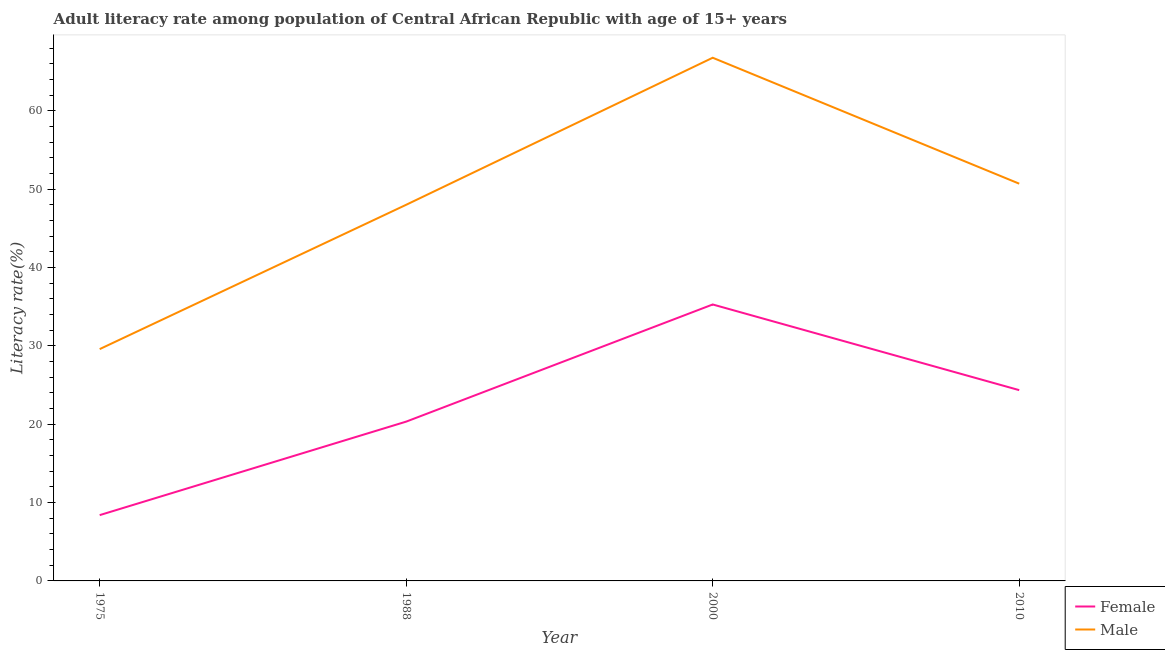What is the female adult literacy rate in 1988?
Make the answer very short. 20.34. Across all years, what is the maximum male adult literacy rate?
Your answer should be compact. 66.79. Across all years, what is the minimum male adult literacy rate?
Provide a short and direct response. 29.59. In which year was the female adult literacy rate maximum?
Provide a succinct answer. 2000. In which year was the female adult literacy rate minimum?
Make the answer very short. 1975. What is the total female adult literacy rate in the graph?
Ensure brevity in your answer.  88.38. What is the difference between the male adult literacy rate in 1975 and that in 1988?
Your answer should be compact. -18.43. What is the difference between the female adult literacy rate in 1975 and the male adult literacy rate in 2000?
Provide a short and direct response. -58.39. What is the average female adult literacy rate per year?
Provide a succinct answer. 22.1. In the year 1975, what is the difference between the female adult literacy rate and male adult literacy rate?
Provide a short and direct response. -21.19. What is the ratio of the male adult literacy rate in 1988 to that in 2010?
Give a very brief answer. 0.95. What is the difference between the highest and the second highest male adult literacy rate?
Your answer should be very brief. 16.08. What is the difference between the highest and the lowest female adult literacy rate?
Give a very brief answer. 26.89. Does the female adult literacy rate monotonically increase over the years?
Ensure brevity in your answer.  No. Is the female adult literacy rate strictly less than the male adult literacy rate over the years?
Your response must be concise. Yes. How many lines are there?
Your answer should be compact. 2. What is the difference between two consecutive major ticks on the Y-axis?
Make the answer very short. 10. Does the graph contain grids?
Offer a terse response. No. How are the legend labels stacked?
Provide a succinct answer. Vertical. What is the title of the graph?
Provide a succinct answer. Adult literacy rate among population of Central African Republic with age of 15+ years. Does "Technicians" appear as one of the legend labels in the graph?
Your response must be concise. No. What is the label or title of the Y-axis?
Your response must be concise. Literacy rate(%). What is the Literacy rate(%) in Female in 1975?
Provide a short and direct response. 8.4. What is the Literacy rate(%) of Male in 1975?
Your answer should be very brief. 29.59. What is the Literacy rate(%) in Female in 1988?
Keep it short and to the point. 20.34. What is the Literacy rate(%) of Male in 1988?
Make the answer very short. 48.02. What is the Literacy rate(%) in Female in 2000?
Provide a short and direct response. 35.29. What is the Literacy rate(%) in Male in 2000?
Your response must be concise. 66.79. What is the Literacy rate(%) of Female in 2010?
Offer a very short reply. 24.36. What is the Literacy rate(%) of Male in 2010?
Your response must be concise. 50.71. Across all years, what is the maximum Literacy rate(%) of Female?
Offer a terse response. 35.29. Across all years, what is the maximum Literacy rate(%) of Male?
Your answer should be very brief. 66.79. Across all years, what is the minimum Literacy rate(%) of Female?
Keep it short and to the point. 8.4. Across all years, what is the minimum Literacy rate(%) of Male?
Ensure brevity in your answer.  29.59. What is the total Literacy rate(%) in Female in the graph?
Give a very brief answer. 88.38. What is the total Literacy rate(%) in Male in the graph?
Offer a terse response. 195.12. What is the difference between the Literacy rate(%) in Female in 1975 and that in 1988?
Make the answer very short. -11.94. What is the difference between the Literacy rate(%) in Male in 1975 and that in 1988?
Your response must be concise. -18.43. What is the difference between the Literacy rate(%) in Female in 1975 and that in 2000?
Give a very brief answer. -26.89. What is the difference between the Literacy rate(%) in Male in 1975 and that in 2000?
Give a very brief answer. -37.2. What is the difference between the Literacy rate(%) of Female in 1975 and that in 2010?
Provide a succinct answer. -15.96. What is the difference between the Literacy rate(%) of Male in 1975 and that in 2010?
Provide a short and direct response. -21.12. What is the difference between the Literacy rate(%) in Female in 1988 and that in 2000?
Ensure brevity in your answer.  -14.95. What is the difference between the Literacy rate(%) in Male in 1988 and that in 2000?
Provide a succinct answer. -18.77. What is the difference between the Literacy rate(%) in Female in 1988 and that in 2010?
Offer a terse response. -4.02. What is the difference between the Literacy rate(%) of Male in 1988 and that in 2010?
Your answer should be compact. -2.69. What is the difference between the Literacy rate(%) in Female in 2000 and that in 2010?
Your response must be concise. 10.94. What is the difference between the Literacy rate(%) in Male in 2000 and that in 2010?
Your answer should be compact. 16.08. What is the difference between the Literacy rate(%) of Female in 1975 and the Literacy rate(%) of Male in 1988?
Provide a short and direct response. -39.62. What is the difference between the Literacy rate(%) in Female in 1975 and the Literacy rate(%) in Male in 2000?
Your answer should be compact. -58.39. What is the difference between the Literacy rate(%) of Female in 1975 and the Literacy rate(%) of Male in 2010?
Your answer should be very brief. -42.31. What is the difference between the Literacy rate(%) of Female in 1988 and the Literacy rate(%) of Male in 2000?
Make the answer very short. -46.45. What is the difference between the Literacy rate(%) in Female in 1988 and the Literacy rate(%) in Male in 2010?
Your answer should be compact. -30.38. What is the difference between the Literacy rate(%) in Female in 2000 and the Literacy rate(%) in Male in 2010?
Your response must be concise. -15.42. What is the average Literacy rate(%) of Female per year?
Offer a very short reply. 22.1. What is the average Literacy rate(%) of Male per year?
Offer a very short reply. 48.78. In the year 1975, what is the difference between the Literacy rate(%) of Female and Literacy rate(%) of Male?
Ensure brevity in your answer.  -21.19. In the year 1988, what is the difference between the Literacy rate(%) of Female and Literacy rate(%) of Male?
Offer a very short reply. -27.68. In the year 2000, what is the difference between the Literacy rate(%) of Female and Literacy rate(%) of Male?
Make the answer very short. -31.5. In the year 2010, what is the difference between the Literacy rate(%) in Female and Literacy rate(%) in Male?
Keep it short and to the point. -26.36. What is the ratio of the Literacy rate(%) of Female in 1975 to that in 1988?
Offer a very short reply. 0.41. What is the ratio of the Literacy rate(%) in Male in 1975 to that in 1988?
Keep it short and to the point. 0.62. What is the ratio of the Literacy rate(%) of Female in 1975 to that in 2000?
Offer a terse response. 0.24. What is the ratio of the Literacy rate(%) in Male in 1975 to that in 2000?
Offer a very short reply. 0.44. What is the ratio of the Literacy rate(%) in Female in 1975 to that in 2010?
Provide a short and direct response. 0.34. What is the ratio of the Literacy rate(%) of Male in 1975 to that in 2010?
Make the answer very short. 0.58. What is the ratio of the Literacy rate(%) in Female in 1988 to that in 2000?
Your response must be concise. 0.58. What is the ratio of the Literacy rate(%) of Male in 1988 to that in 2000?
Ensure brevity in your answer.  0.72. What is the ratio of the Literacy rate(%) of Female in 1988 to that in 2010?
Your response must be concise. 0.83. What is the ratio of the Literacy rate(%) in Male in 1988 to that in 2010?
Your answer should be compact. 0.95. What is the ratio of the Literacy rate(%) of Female in 2000 to that in 2010?
Provide a succinct answer. 1.45. What is the ratio of the Literacy rate(%) in Male in 2000 to that in 2010?
Offer a terse response. 1.32. What is the difference between the highest and the second highest Literacy rate(%) of Female?
Your answer should be compact. 10.94. What is the difference between the highest and the second highest Literacy rate(%) of Male?
Your answer should be very brief. 16.08. What is the difference between the highest and the lowest Literacy rate(%) in Female?
Your answer should be compact. 26.89. What is the difference between the highest and the lowest Literacy rate(%) in Male?
Make the answer very short. 37.2. 